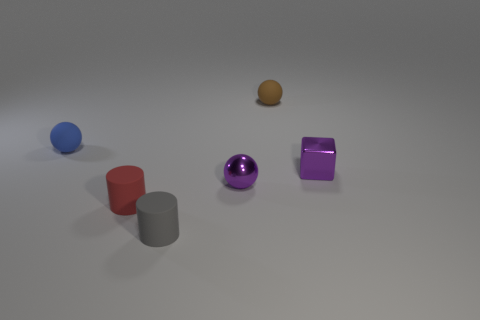There is a rubber object that is behind the red object and right of the tiny blue rubber sphere; what shape is it?
Make the answer very short. Sphere. There is a small ball that is in front of the tiny purple metal object to the right of the purple shiny ball that is behind the tiny gray cylinder; what is its color?
Offer a very short reply. Purple. Are there more red things to the right of the small metal block than tiny red objects that are on the right side of the red cylinder?
Offer a terse response. No. How many other objects are the same size as the gray rubber thing?
Your answer should be very brief. 5. There is a metallic thing that is the same color as the tiny metal cube; what is its size?
Your answer should be very brief. Small. What is the material of the purple thing that is behind the tiny purple object that is in front of the purple shiny block?
Offer a very short reply. Metal. Are there any red rubber things behind the shiny block?
Provide a succinct answer. No. Is the number of rubber cylinders to the left of the blue sphere greater than the number of tiny blue matte things?
Make the answer very short. No. Is there a block that has the same color as the metallic ball?
Keep it short and to the point. Yes. What is the color of the rubber cylinder that is the same size as the gray rubber thing?
Your response must be concise. Red. 